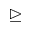<formula> <loc_0><loc_0><loc_500><loc_500>\triangleright e q</formula> 